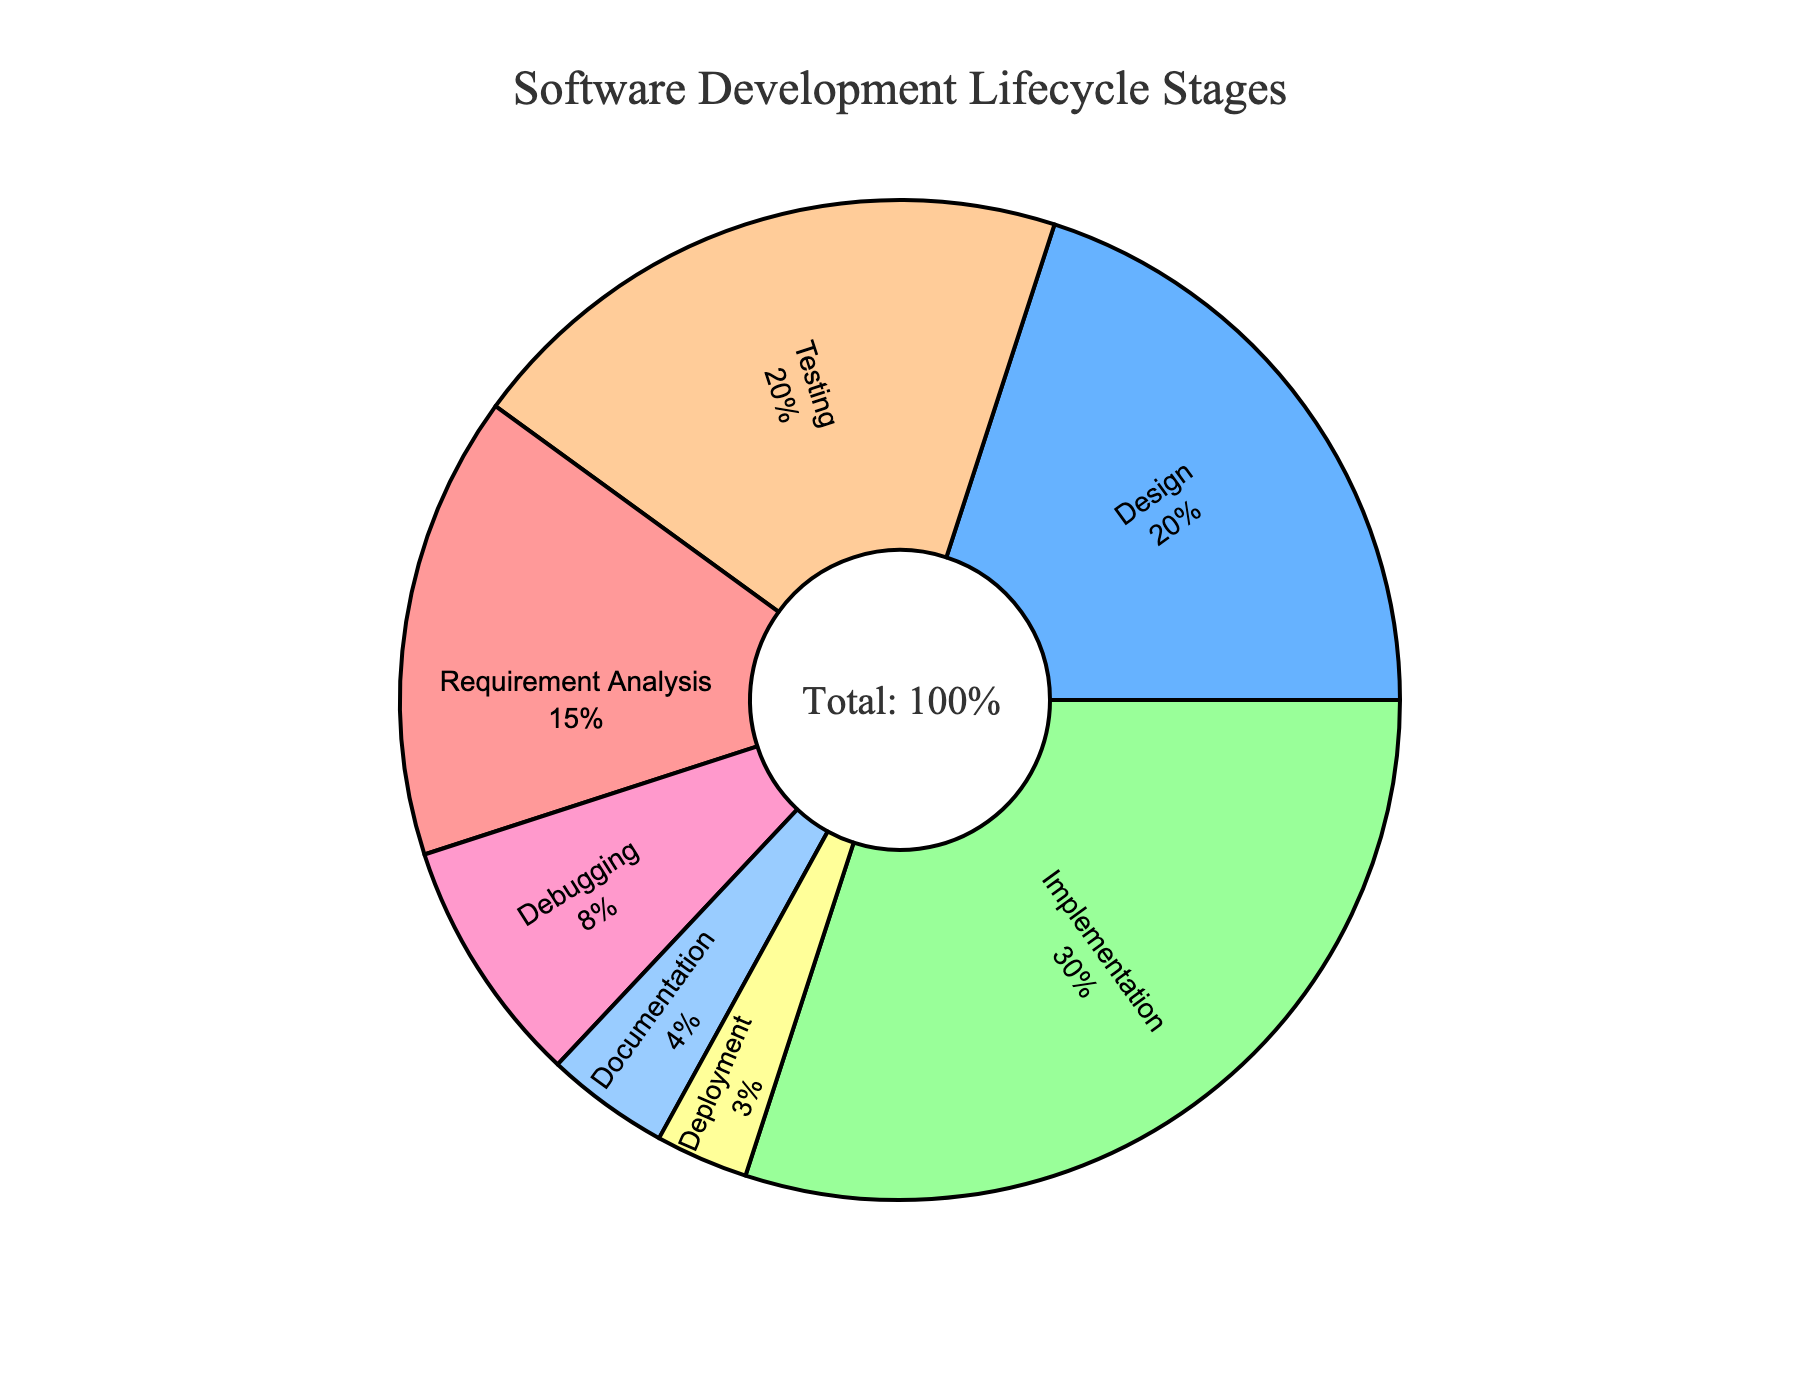What stage has the largest percentage allocation? The figure shows the allocation of time spent on different stages of the software development lifecycle. Comparing the percentages, the 'Implementation' stage has 30%, which is the highest.
Answer: Implementation What is the combined percentage of the Design and Testing stages? From the figure, Design has 20% and Testing also has 20%. Adding these two percentages: 20% + 20% = 40%.
Answer: 40% How much more time is spent on Implementation compared to Deployment? The Implementation stage is 30%, and the Deployment stage is 3%. Subtracting these: 30% - 3% = 27%.
Answer: 27% Which stage takes the least amount of time? By observing the smallest segment of the pie chart, the Deployment stage has the smallest allocation at 3%.
Answer: Deployment What percentage of time is spent on activities other than Implementation and Testing? The total percentage is 100%. Subtracting the sum of Implementation (30%) and Testing (20%): 100% - 30% - 20% = 50%.
Answer: 50% Is more time allocated to Requirement Analysis or Debugging? Requirement Analysis is allocated 15%, while Debugging is allocated 8%. Therefore, more time is allocated to Requirement Analysis.
Answer: Requirement Analysis What is the difference in time allocation between Documentation and Deployment? Documentation is allocated 4%, and Deployment is 3%. The difference is 4% - 3% = 1%.
Answer: 1% What percentage of the pie chart is made up of Design, Debugging, and Documentation combined? Design is 20%, Debugging is 8%, and Documentation is 4%. Adding these: 20% + 8% + 4% = 32%.
Answer: 32% What are the colors used for the segments representing Implementation and Testing stages? The Implementation stage is shown in a light green color and the Testing stage is shown in a light orange color.
Answer: Light green and light orange Which stages' segments are adjacent to the Implementation segment in the pie chart? The segments for 'Testing' and 'Debugging' are adjacent to the 'Implementation' segment in the pie chart.
Answer: Testing and Debugging 